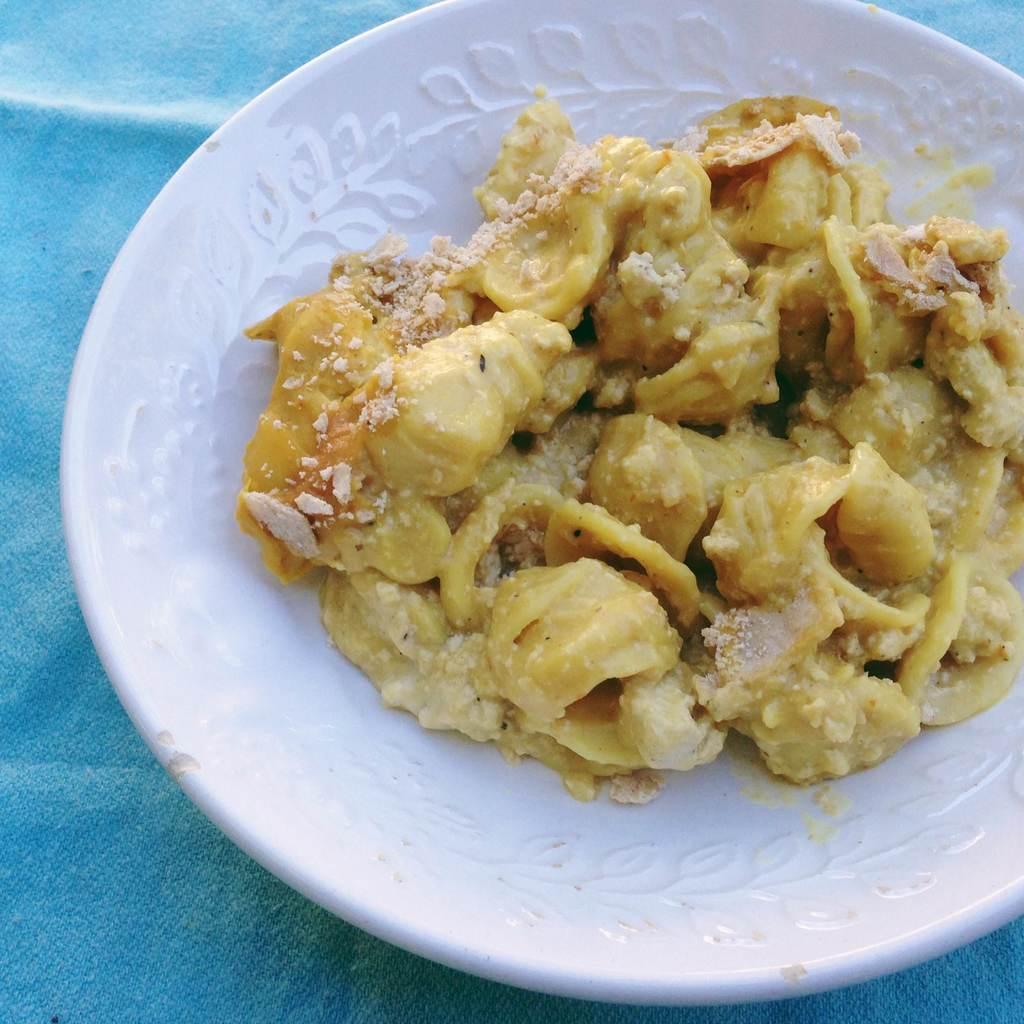What is on the plate in the image? There are food items on a plate in the image. Where might the plate be located? The plate may be on a table. In what type of setting might the image have been taken? The image may have been taken in a room. How many chairs can be seen in the image? There is no mention of chairs in the provided facts, so it cannot be determined how many chairs are present in the image. 